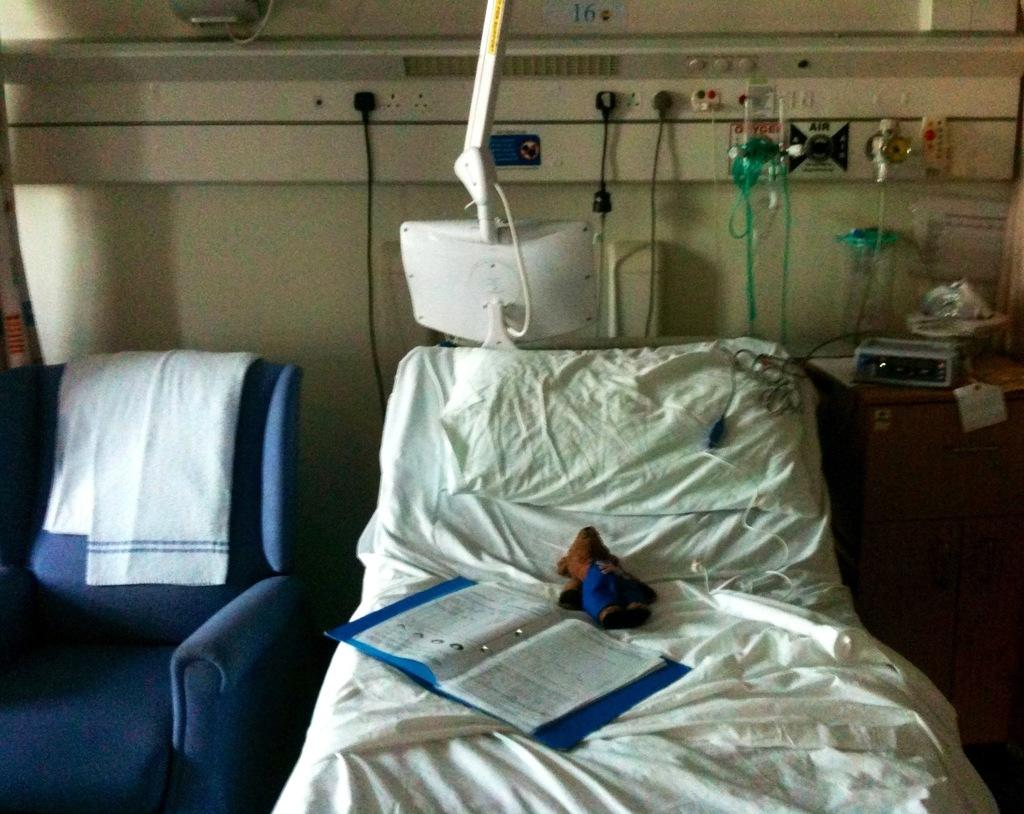What type of furniture is present in the image? There is a bed and a chair in the image. Can you describe any other objects in the image? There are some unspecified objects in the image. How is the rake being used in the image? There is no rake present in the image. What type of test is being conducted in the image? There is no test being conducted in the image. 